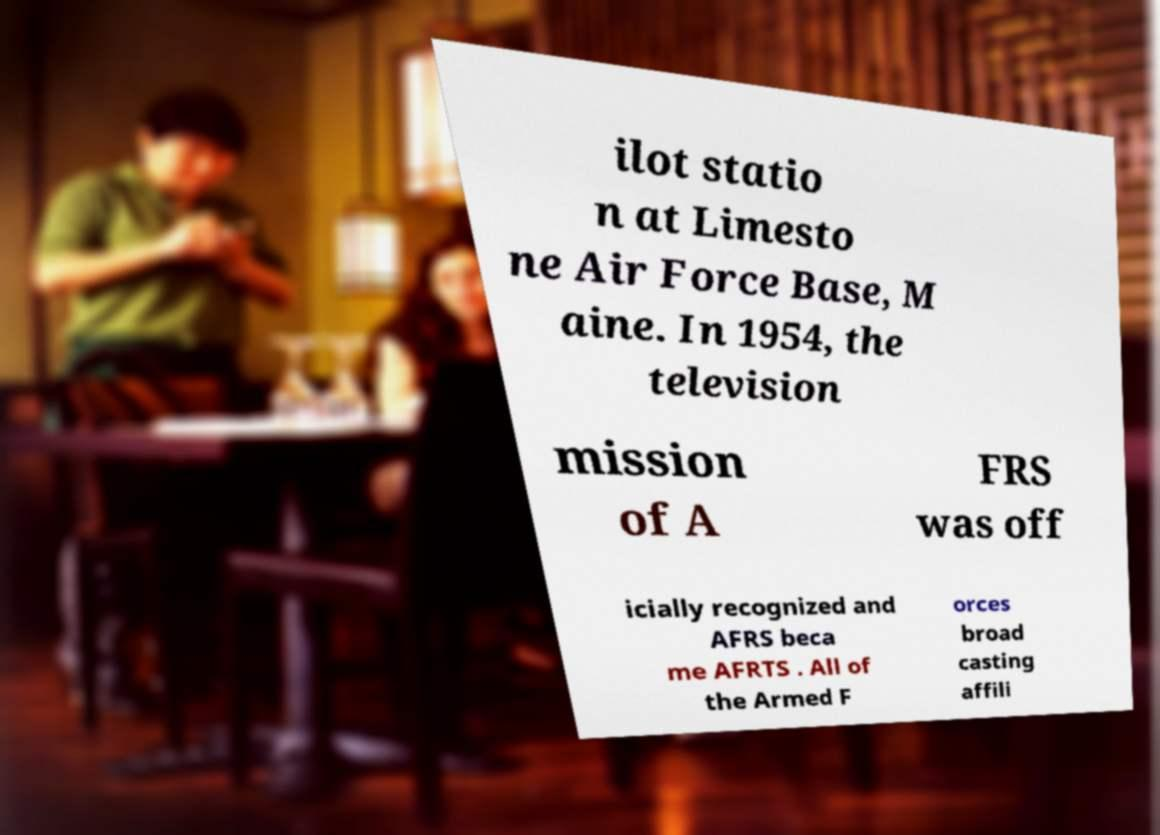Please identify and transcribe the text found in this image. ilot statio n at Limesto ne Air Force Base, M aine. In 1954, the television mission of A FRS was off icially recognized and AFRS beca me AFRTS . All of the Armed F orces broad casting affili 